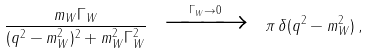<formula> <loc_0><loc_0><loc_500><loc_500>\frac { m _ { W } \Gamma _ { W } } { ( q ^ { 2 } - m _ { W } ^ { 2 } ) ^ { 2 } + m _ { W } ^ { 2 } \Gamma _ { W } ^ { 2 } } \ \xrightarrow { \Gamma _ { W } \rightarrow 0 } \ \pi \, \delta ( q ^ { 2 } - m _ { W } ^ { 2 } ) \, ,</formula> 